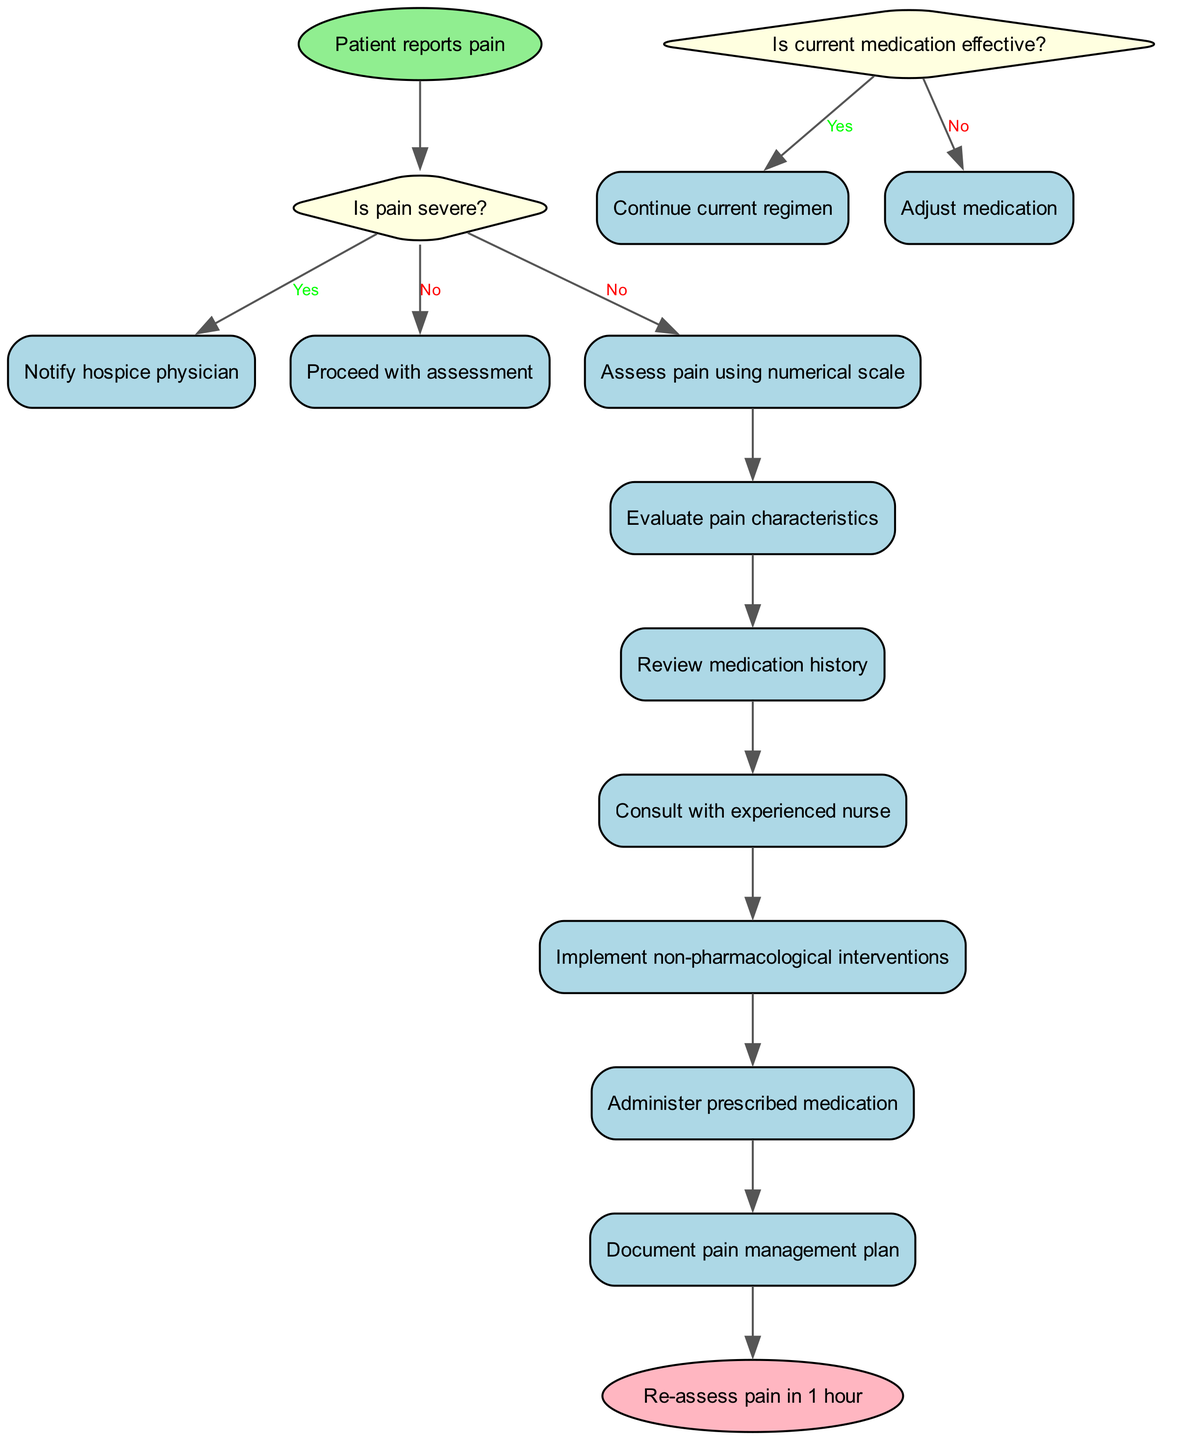What is the first action taken when a patient reports pain? The flowchart starts with the action "Patient reports pain," indicating that this is the initial step to trigger the pain assessment and management process.
Answer: Patient reports pain How many decision nodes are present in the flowchart? There are two decision nodes identified in the flowchart, each representing a critical decision point regarding the severity of the pain and the effectiveness of medication.
Answer: 2 What happens if the pain is severe? If the pain is classified as severe, the flowchart indicates to "Notify hospice physician," making this action the subsequent step after acknowledging the severity of the pain.
Answer: Notify hospice physician What action is taken if the current medication is not effective? When the current medication is deemed ineffective, the flowchart instructs to "Adjust medication," which signifies a change in the treatment strategy for the patient’s pain management.
Answer: Adjust medication Which process follows after assessing pain using the numerical scale? After "Assess pain using numerical scale," the next process to follow in the flowchart is "Evaluate pain characteristics," indicating a sequential evaluation of the patient's pain.
Answer: Evaluate pain characteristics What is the final step in the pain management process as indicated in the flowchart? The last step specified in the flowchart is "Re-assess pain in 1 hour," indicating that monitoring the patient's pain levels is a crucial final action after implementing the pain management plan.
Answer: Re-assess pain in 1 hour Where does the flowchart direct after the decision of whether the pain is severe or not? If the pain is not severe, the flowchart directs to "Proceed with assessment," showing that a less severe evaluation leads to further assessment and management steps.
Answer: Proceed with assessment What color are the decision nodes in the diagram? The decision nodes in the flowchart are filled with light yellow, visually distinguishing them from other types of nodes in the diagram.
Answer: Light yellow 